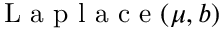Convert formula to latex. <formula><loc_0><loc_0><loc_500><loc_500>{ L a p l a c e } ( \mu , b )</formula> 